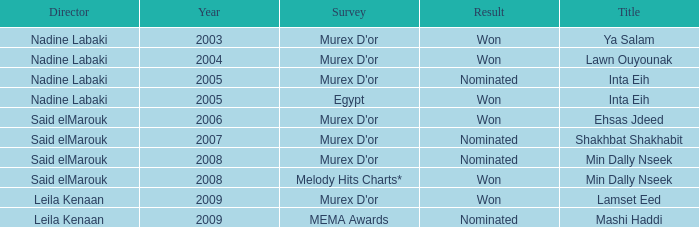Who is the director with the Min Dally Nseek title, and won? Said elMarouk. 